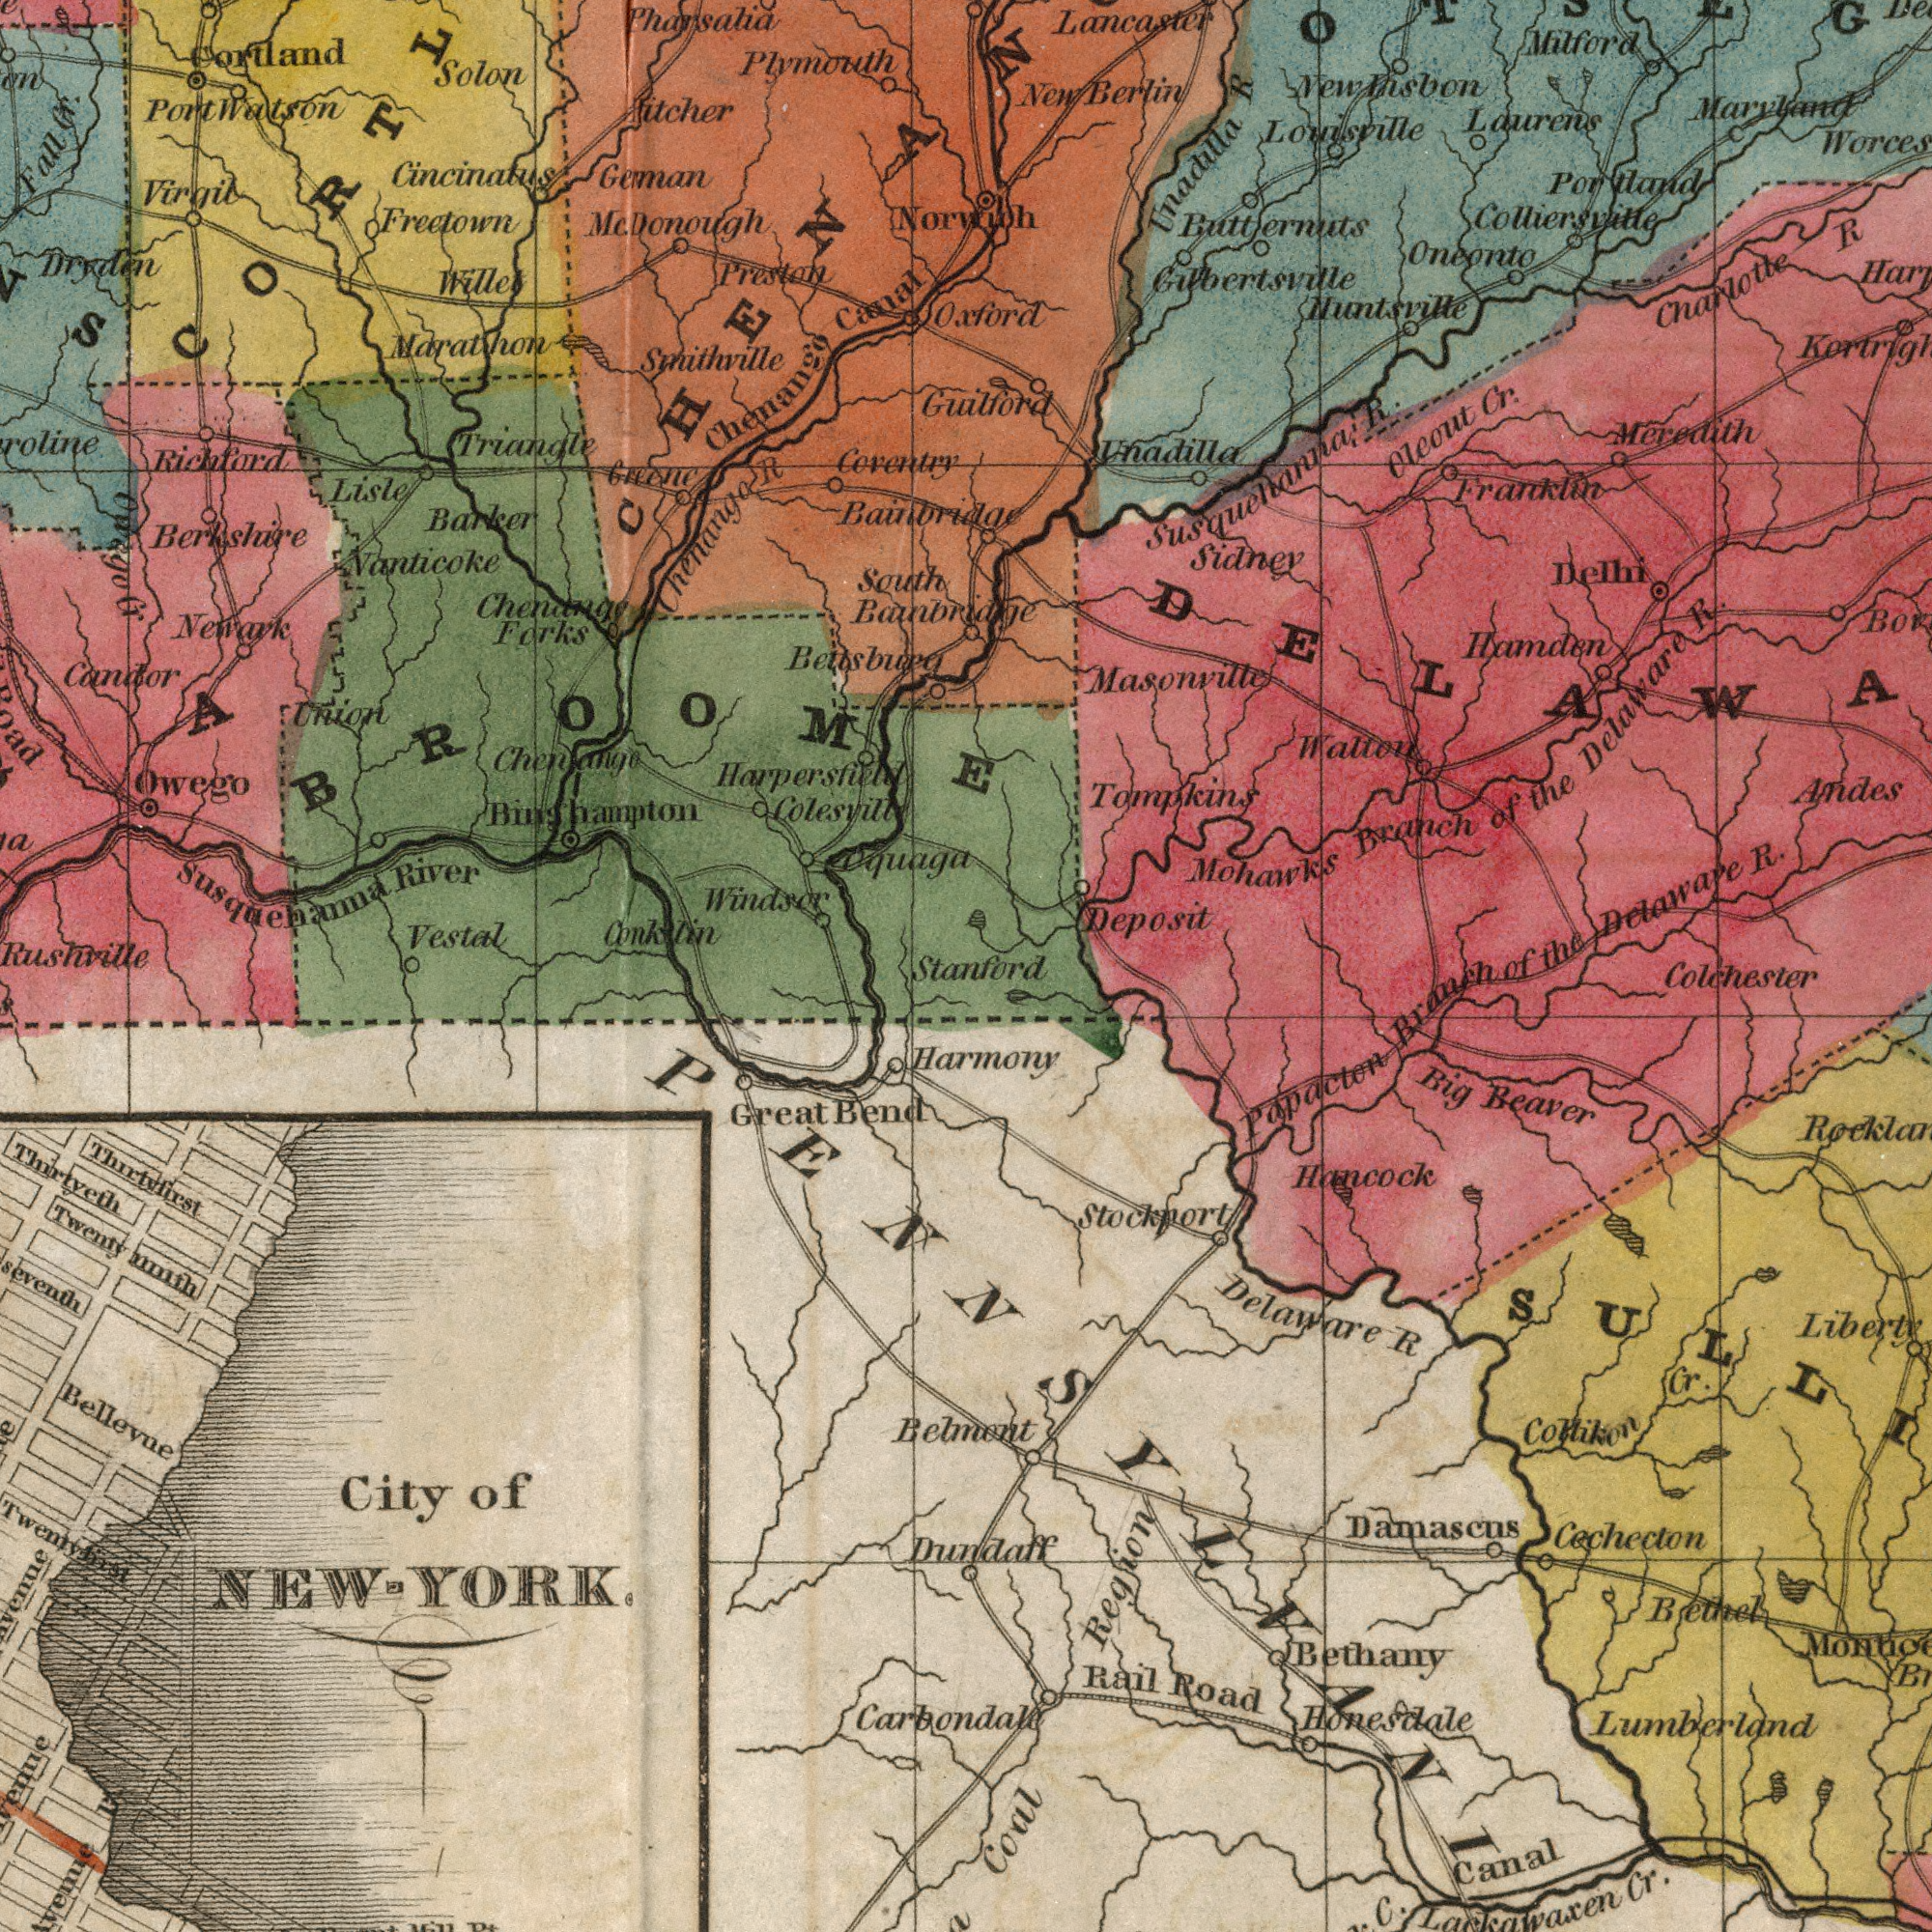What text is visible in the upper-right corner? Norwich Tompkins Mohawks Branch of the Delaware R. Andes Buttermuts Laurens of the Delaware R. Hamden Franklin Oneonto Unadilla Milford Maryland Huntsville Sidney Unadilla R Deposit New knsbon Colliersville Gilbertsville Masonville Oleout Cr. Walton Susquehanna R. Charlotte R Delhi Louisville Oxford Lancaster Guilford Meredith Portland New Berlin What text is visible in the lower-right corner? Papacten Branch Behnent Dundaff Delaware R Cechecton Hancock Honesdale Big Beaver Damascus Region Coal Liberty Lackawaxen Cr. Bethany Collikon Cr. Rail Road Colchester Harmony Stockport Bethel Lumberland Canal Stanford What text is visible in the upper-left corner? Smithville Berkshire Bettsburg McDonough Harperstield Colesvill Cincinatus Plymouth Windsor Port Watson Nanticoke Barker Susqueehamaa River Freetown Cortland Solon Geman Vestal Lisle Virgil Marathon Pharsalia Preston Rickford Candor Dryden Bainbridge Chemango Canal Chenamye Coventry Fitcher Chenango Forks South Bainbridge Greene Willet Conklin Union Fall Cr. Newark Chanango R Triangle Onago Cr Binghampton Rushville Owego Oquaga BROOME ###A What text can you see in the bottom-left section? Thirtyeth Thirtyfirst Bellevue Great Bend Twentyninth Carbondale Twentyfirst City of NEW - YORK. 